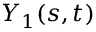<formula> <loc_0><loc_0><loc_500><loc_500>Y _ { 1 } ( s , t )</formula> 